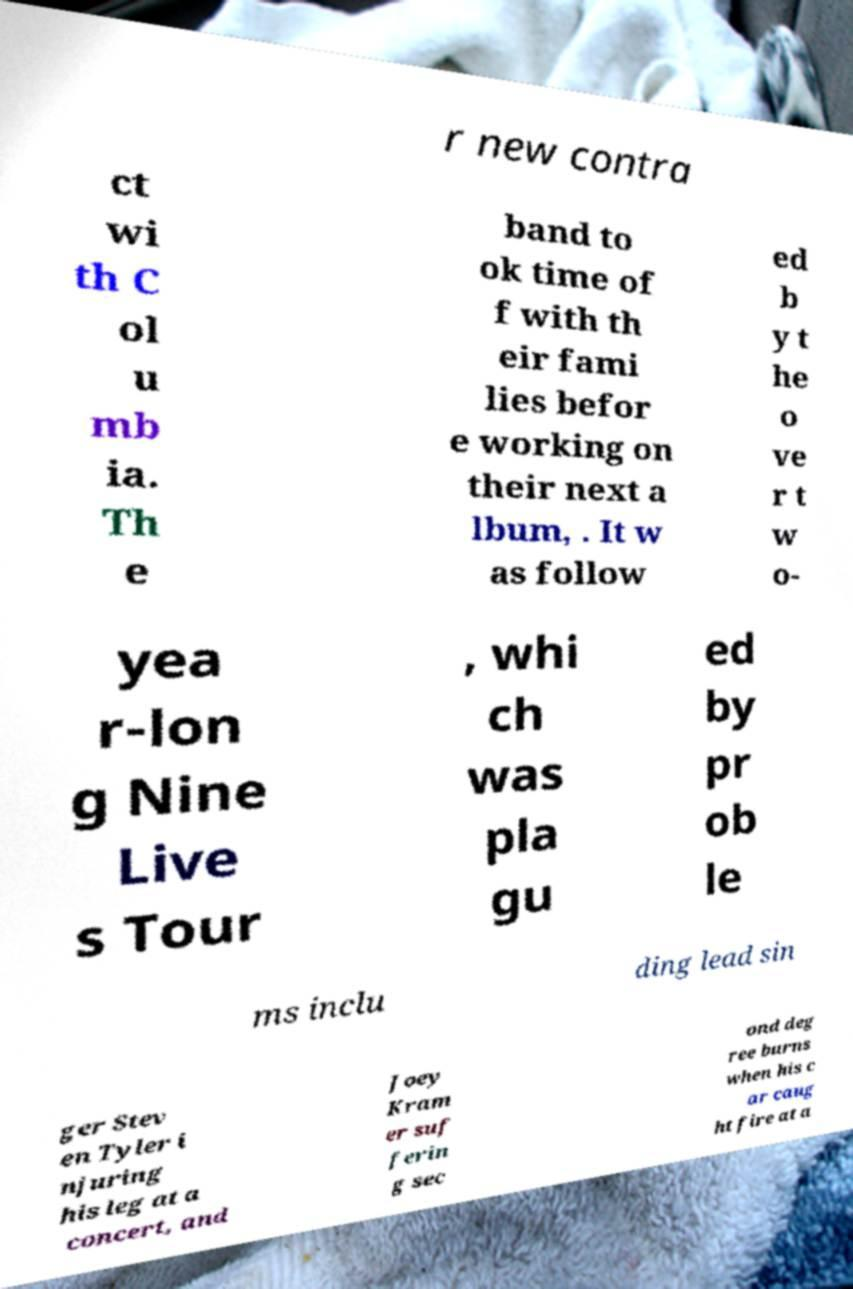Could you extract and type out the text from this image? r new contra ct wi th C ol u mb ia. Th e band to ok time of f with th eir fami lies befor e working on their next a lbum, . It w as follow ed b y t he o ve r t w o- yea r-lon g Nine Live s Tour , whi ch was pla gu ed by pr ob le ms inclu ding lead sin ger Stev en Tyler i njuring his leg at a concert, and Joey Kram er suf ferin g sec ond deg ree burns when his c ar caug ht fire at a 